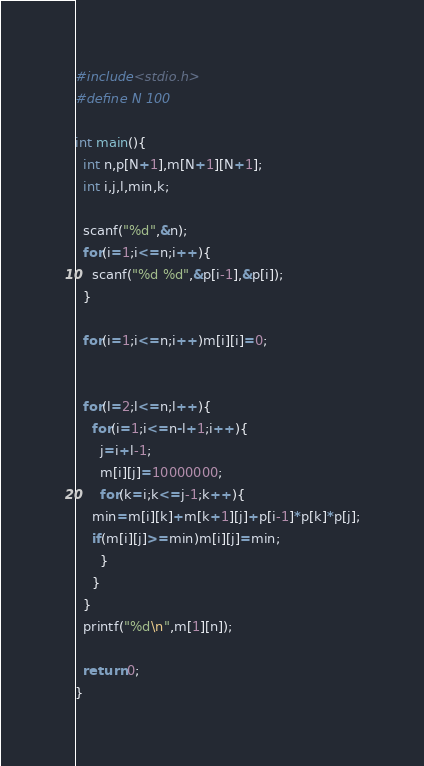<code> <loc_0><loc_0><loc_500><loc_500><_C_>#include<stdio.h>
#define N 100

int main(){
  int n,p[N+1],m[N+1][N+1];
  int i,j,l,min,k;
  
  scanf("%d",&n);
  for(i=1;i<=n;i++){
    scanf("%d %d",&p[i-1],&p[i]);
  }

  for(i=1;i<=n;i++)m[i][i]=0;

  
  for(l=2;l<=n;l++){
    for(i=1;i<=n-l+1;i++){
      j=i+l-1;
      m[i][j]=10000000;
      for(k=i;k<=j-1;k++){
	min=m[i][k]+m[k+1][j]+p[i-1]*p[k]*p[j];
	if(m[i][j]>=min)m[i][j]=min;
      }
    }
  }
  printf("%d\n",m[1][n]);

  return 0;
}</code> 